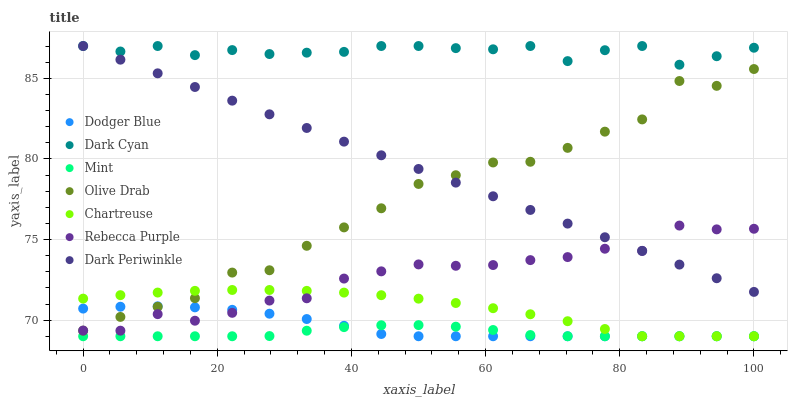Does Mint have the minimum area under the curve?
Answer yes or no. Yes. Does Dark Cyan have the maximum area under the curve?
Answer yes or no. Yes. Does Dodger Blue have the minimum area under the curve?
Answer yes or no. No. Does Dodger Blue have the maximum area under the curve?
Answer yes or no. No. Is Dark Periwinkle the smoothest?
Answer yes or no. Yes. Is Olive Drab the roughest?
Answer yes or no. Yes. Is Dodger Blue the smoothest?
Answer yes or no. No. Is Dodger Blue the roughest?
Answer yes or no. No. Does Chartreuse have the lowest value?
Answer yes or no. Yes. Does Rebecca Purple have the lowest value?
Answer yes or no. No. Does Dark Periwinkle have the highest value?
Answer yes or no. Yes. Does Dodger Blue have the highest value?
Answer yes or no. No. Is Rebecca Purple less than Dark Cyan?
Answer yes or no. Yes. Is Dark Cyan greater than Olive Drab?
Answer yes or no. Yes. Does Dodger Blue intersect Rebecca Purple?
Answer yes or no. Yes. Is Dodger Blue less than Rebecca Purple?
Answer yes or no. No. Is Dodger Blue greater than Rebecca Purple?
Answer yes or no. No. Does Rebecca Purple intersect Dark Cyan?
Answer yes or no. No. 